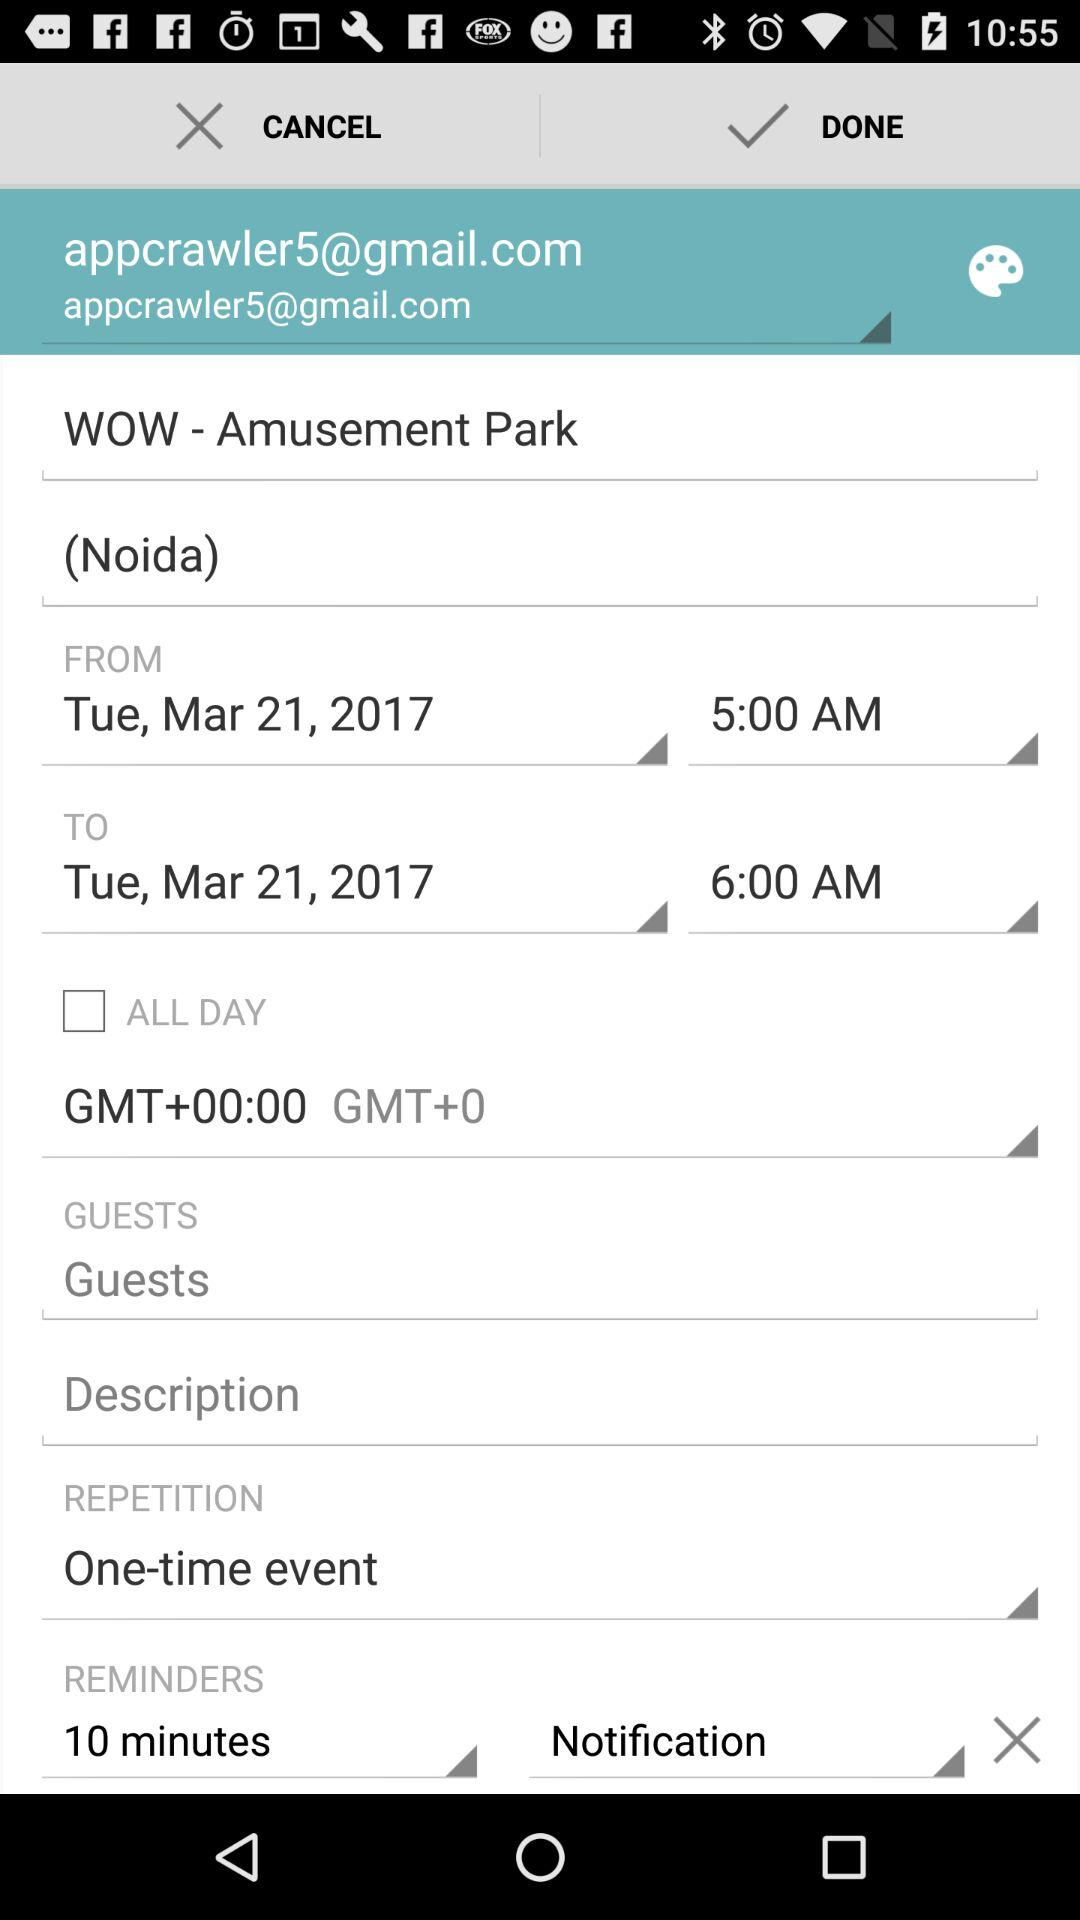What's the scheduled entry time and date for "WOW - Amusement Park"? The scheduled entry time and date are Tuesday, March 21, 2017 at 5:00 AM. 